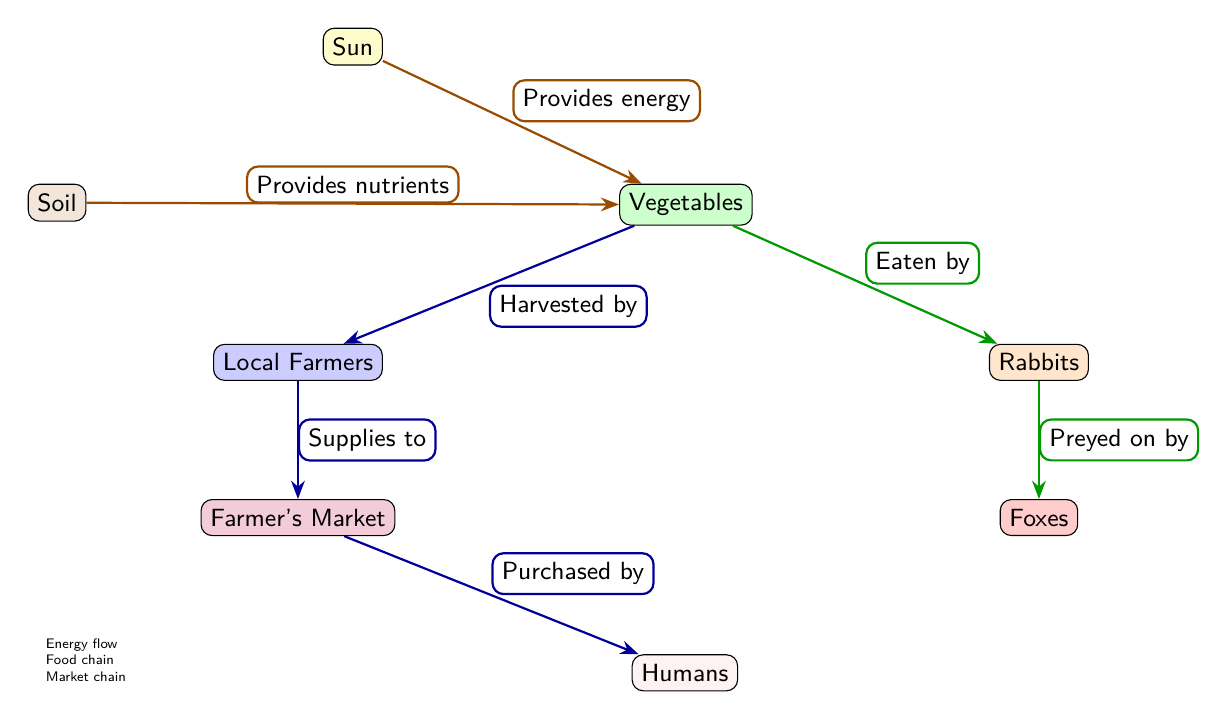What provides energy to the vegetables? The diagram shows that the "Sun" provides energy to the "Vegetables" through the arrow labeled "Provides energy."
Answer: Sun How many different types of organisms are present in the food chain? The diagram includes three types of organisms: "Vegetables," "Rabbits," and "Foxes." Thus, the total count of organisms is three.
Answer: 3 What does the soil provide to the vegetables? The diagram indicates that "Soil" provides "Nutrients" to the "Vegetables" as depicted by the arrow labeled "Provides nutrients."
Answer: Nutrients Who harvests the vegetables from the plants? The diagram shows that the "Local Farmers" are responsible for harvesting the "Vegetables," as indicated by the arrow labeled "Harvested by."
Answer: Local Farmers What happens to rabbits in the food chain? According to the diagram, "Rabbits" are eaten by "Foxes," demonstrated by the arrow labeled "Preyed on by."
Answer: Preyed on by What is the last step in the journey from plant to human consumption? The diagram illustrates that the last step occurs when the "Humans" purchase from the "Farmer's Market," as shown by the arrow labeled "Purchased by."
Answer: Purchased by Which component indicates the market chain? The diagram uses a blue arrow style to denote the market chain in the sequence, including connections from "Local Farmers" to "Farmer's Market" to "Humans."
Answer: Blue arrow style What role do local farmers play in this food chain? "Local Farmers" are shown as a crucial part of the food chain that supplies harvested vegetables to the "Farmer's Market," as described by the arrow labeled "Supplies to."
Answer: Supplies to 